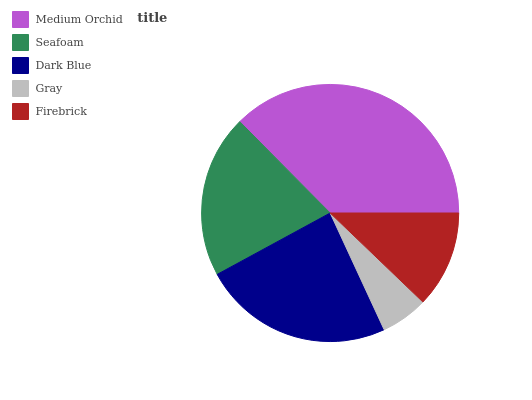Is Gray the minimum?
Answer yes or no. Yes. Is Medium Orchid the maximum?
Answer yes or no. Yes. Is Seafoam the minimum?
Answer yes or no. No. Is Seafoam the maximum?
Answer yes or no. No. Is Medium Orchid greater than Seafoam?
Answer yes or no. Yes. Is Seafoam less than Medium Orchid?
Answer yes or no. Yes. Is Seafoam greater than Medium Orchid?
Answer yes or no. No. Is Medium Orchid less than Seafoam?
Answer yes or no. No. Is Seafoam the high median?
Answer yes or no. Yes. Is Seafoam the low median?
Answer yes or no. Yes. Is Gray the high median?
Answer yes or no. No. Is Dark Blue the low median?
Answer yes or no. No. 